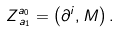Convert formula to latex. <formula><loc_0><loc_0><loc_500><loc_500>Z _ { \, a _ { 1 } } ^ { a _ { 0 } } = \left ( \partial ^ { i } , M \right ) .</formula> 